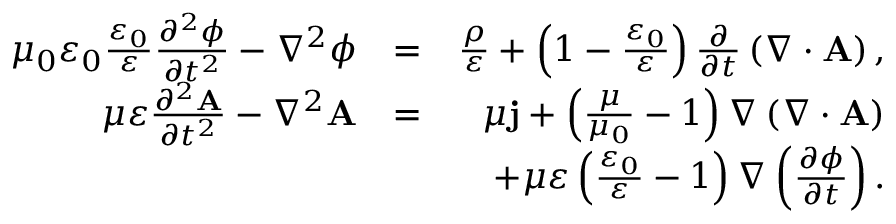Convert formula to latex. <formula><loc_0><loc_0><loc_500><loc_500>\begin{array} { r l r } { \mu _ { 0 } \varepsilon _ { 0 } \frac { \varepsilon _ { 0 } } { \varepsilon } \frac { \partial ^ { 2 } \phi } { \partial t ^ { 2 } } - \nabla ^ { 2 } \phi } & { = } & { \frac { \rho } { \varepsilon } + \left ( 1 - \frac { \varepsilon _ { 0 } } { \varepsilon } \right ) \frac { \partial } { \partial t } \left ( \nabla \cdot A \right ) , } \\ { \mu \varepsilon \frac { \partial ^ { 2 } A } { \partial t ^ { 2 } } - \nabla ^ { 2 } A } & { = } & { \mu j + \left ( \frac { \mu } { \mu _ { 0 } } - 1 \right ) \nabla \left ( \nabla \cdot A \right ) } \\ & { + \mu \varepsilon \left ( \frac { \varepsilon _ { 0 } } { \varepsilon } - 1 \right ) \nabla \left ( \frac { \partial \phi } { \partial t } \right ) . } \end{array}</formula> 